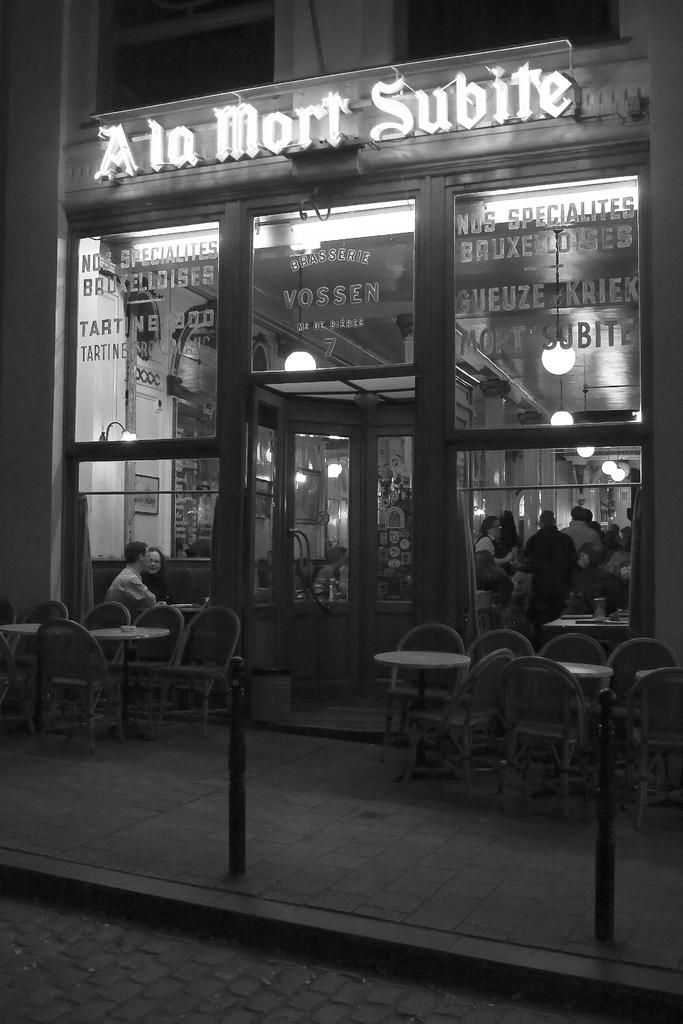What is the color scheme of the image? The image is black and white. What type of establishment is depicted in the image? It is a picture of a store. Are there any people present in the store? Yes, there are people in the store. What type of furniture is available in the store? There are tables and chairs in the store. What can be seen outside the store in the image? There is a road visible in the image. What type of flowers are being sold at the store in the image? There is no indication of flowers being sold in the store in the image. 